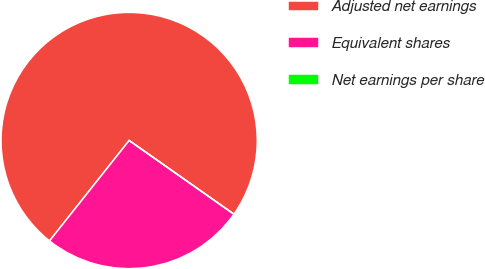Convert chart. <chart><loc_0><loc_0><loc_500><loc_500><pie_chart><fcel>Adjusted net earnings<fcel>Equivalent shares<fcel>Net earnings per share<nl><fcel>74.09%<fcel>25.91%<fcel>0.0%<nl></chart> 